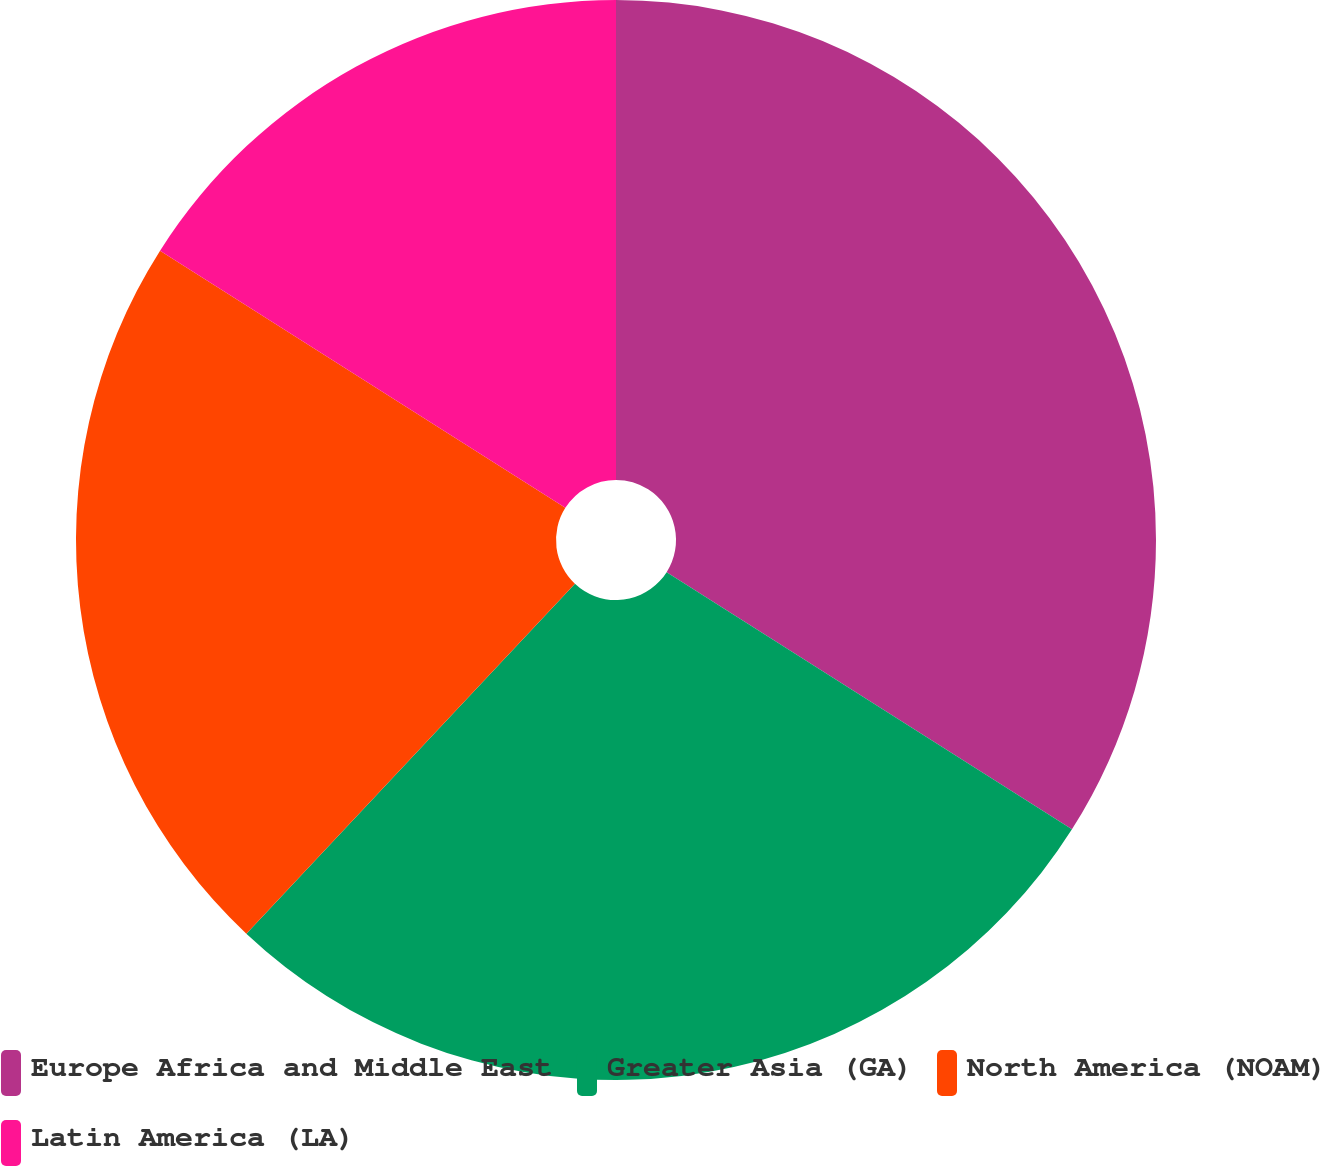Convert chart. <chart><loc_0><loc_0><loc_500><loc_500><pie_chart><fcel>Europe Africa and Middle East<fcel>Greater Asia (GA)<fcel>North America (NOAM)<fcel>Latin America (LA)<nl><fcel>34.0%<fcel>28.0%<fcel>22.0%<fcel>16.0%<nl></chart> 